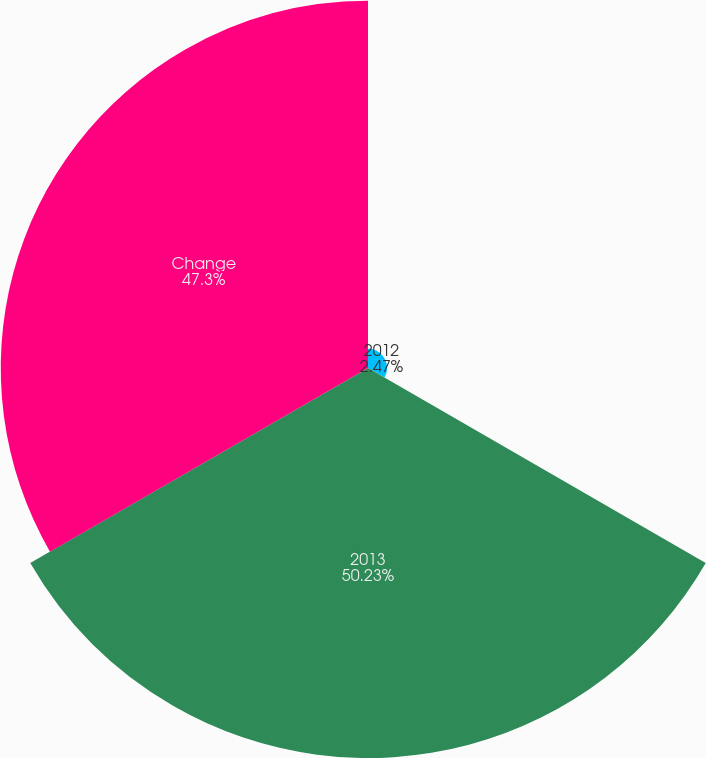Convert chart to OTSL. <chart><loc_0><loc_0><loc_500><loc_500><pie_chart><fcel>2012<fcel>2013<fcel>Change<nl><fcel>2.47%<fcel>50.23%<fcel>47.3%<nl></chart> 